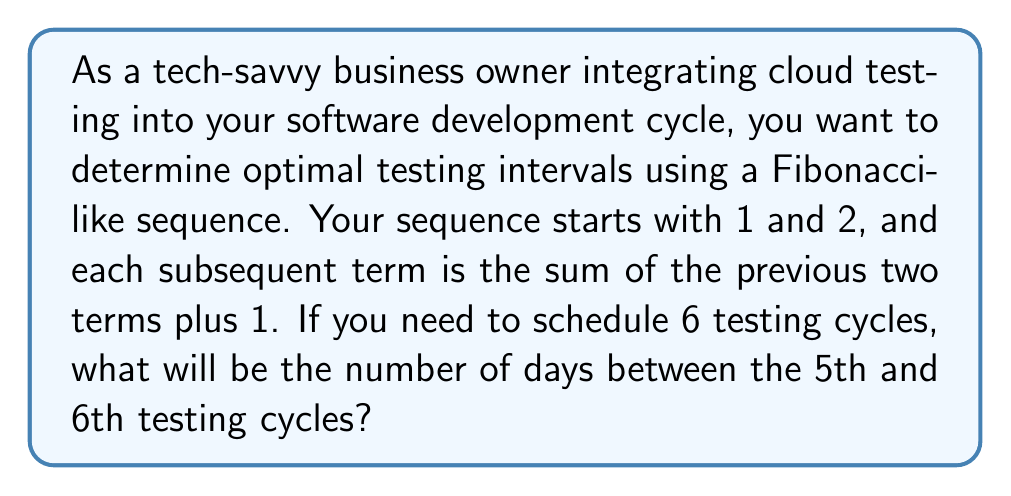What is the answer to this math problem? Let's approach this step-by-step:

1) First, let's generate the Fibonacci-like sequence:
   
   $a_1 = 1$
   $a_2 = 2$
   $a_n = a_{n-1} + a_{n-2} + 1$ for $n > 2$

2) Let's calculate the first 6 terms:
   
   $a_1 = 1$
   $a_2 = 2$
   $a_3 = a_2 + a_1 + 1 = 2 + 1 + 1 = 4$
   $a_4 = a_3 + a_2 + 1 = 4 + 2 + 1 = 7$
   $a_5 = a_4 + a_3 + 1 = 7 + 4 + 1 = 12$
   $a_6 = a_5 + a_4 + 1 = 12 + 7 + 1 = 20$

3) The sequence is now: 1, 2, 4, 7, 12, 20

4) The question asks for the number of days between the 5th and 6th testing cycles.
   This is the difference between the 6th and 5th terms:

   $a_6 - a_5 = 20 - 12 = 8$

Therefore, there will be 8 days between the 5th and 6th testing cycles.
Answer: 8 days 